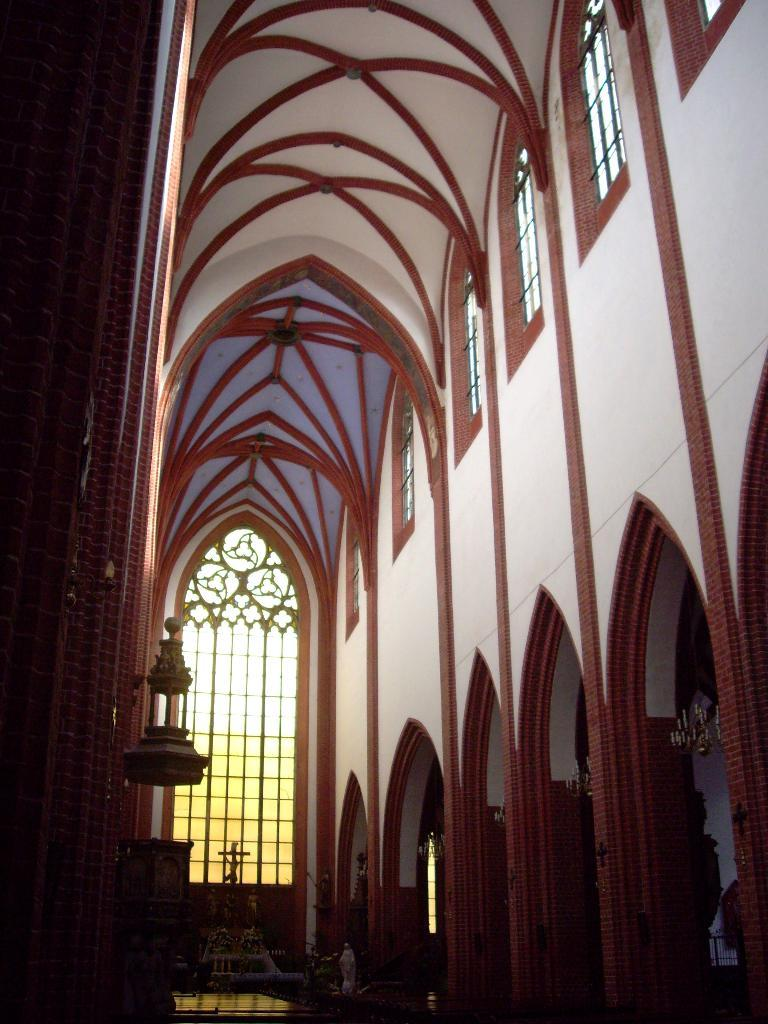What is the main subject in the foreground of the image? The image shows a church wall in the foreground. What other architectural feature can be seen in the image? The image shows a rooftop. When was the image taken? The image was taken during the day. Where was the image taken? The image was taken at a church. What type of hole can be seen in the church wall in the image? There is no hole visible in the church wall in the image. What type of skin can be seen on the rooftop in the image? There is no skin or any living organism visible in the image; it shows a church wall and a rooftop. 